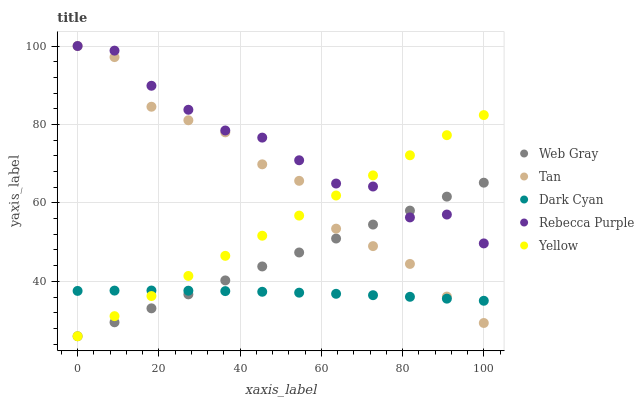Does Dark Cyan have the minimum area under the curve?
Answer yes or no. Yes. Does Rebecca Purple have the maximum area under the curve?
Answer yes or no. Yes. Does Tan have the minimum area under the curve?
Answer yes or no. No. Does Tan have the maximum area under the curve?
Answer yes or no. No. Is Web Gray the smoothest?
Answer yes or no. Yes. Is Tan the roughest?
Answer yes or no. Yes. Is Tan the smoothest?
Answer yes or no. No. Is Web Gray the roughest?
Answer yes or no. No. Does Web Gray have the lowest value?
Answer yes or no. Yes. Does Tan have the lowest value?
Answer yes or no. No. Does Rebecca Purple have the highest value?
Answer yes or no. Yes. Does Web Gray have the highest value?
Answer yes or no. No. Is Dark Cyan less than Rebecca Purple?
Answer yes or no. Yes. Is Rebecca Purple greater than Dark Cyan?
Answer yes or no. Yes. Does Tan intersect Web Gray?
Answer yes or no. Yes. Is Tan less than Web Gray?
Answer yes or no. No. Is Tan greater than Web Gray?
Answer yes or no. No. Does Dark Cyan intersect Rebecca Purple?
Answer yes or no. No. 